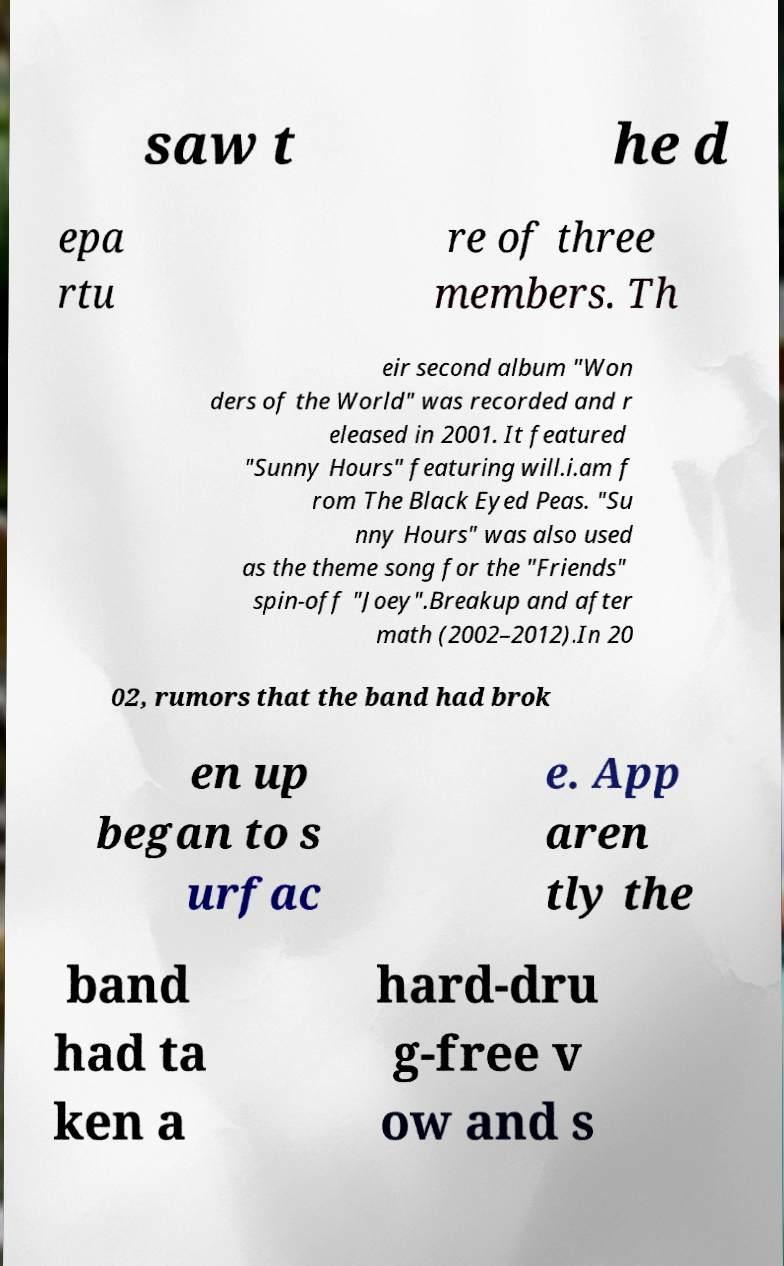For documentation purposes, I need the text within this image transcribed. Could you provide that? saw t he d epa rtu re of three members. Th eir second album "Won ders of the World" was recorded and r eleased in 2001. It featured "Sunny Hours" featuring will.i.am f rom The Black Eyed Peas. "Su nny Hours" was also used as the theme song for the "Friends" spin-off "Joey".Breakup and after math (2002–2012).In 20 02, rumors that the band had brok en up began to s urfac e. App aren tly the band had ta ken a hard-dru g-free v ow and s 